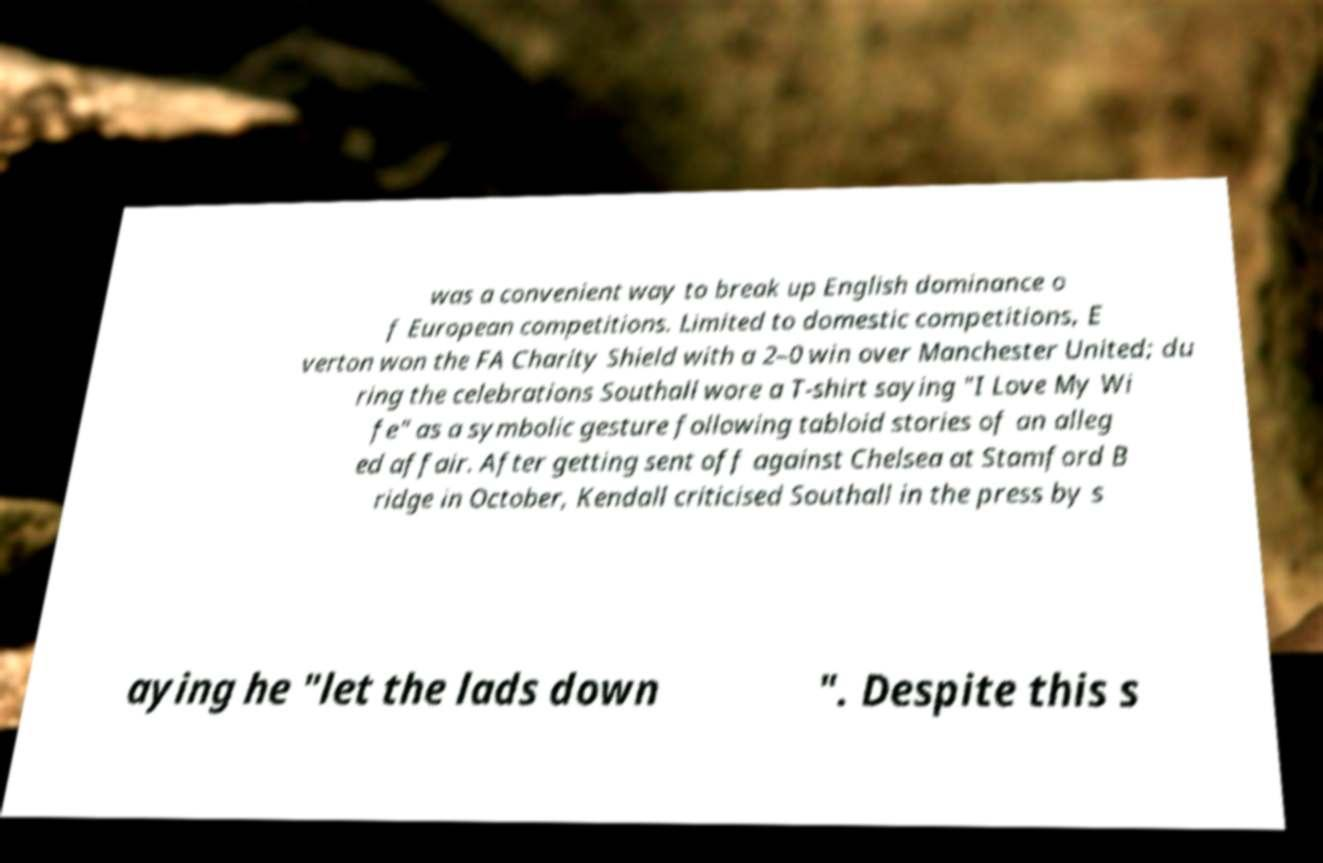Could you assist in decoding the text presented in this image and type it out clearly? was a convenient way to break up English dominance o f European competitions. Limited to domestic competitions, E verton won the FA Charity Shield with a 2–0 win over Manchester United; du ring the celebrations Southall wore a T-shirt saying "I Love My Wi fe" as a symbolic gesture following tabloid stories of an alleg ed affair. After getting sent off against Chelsea at Stamford B ridge in October, Kendall criticised Southall in the press by s aying he "let the lads down ". Despite this s 